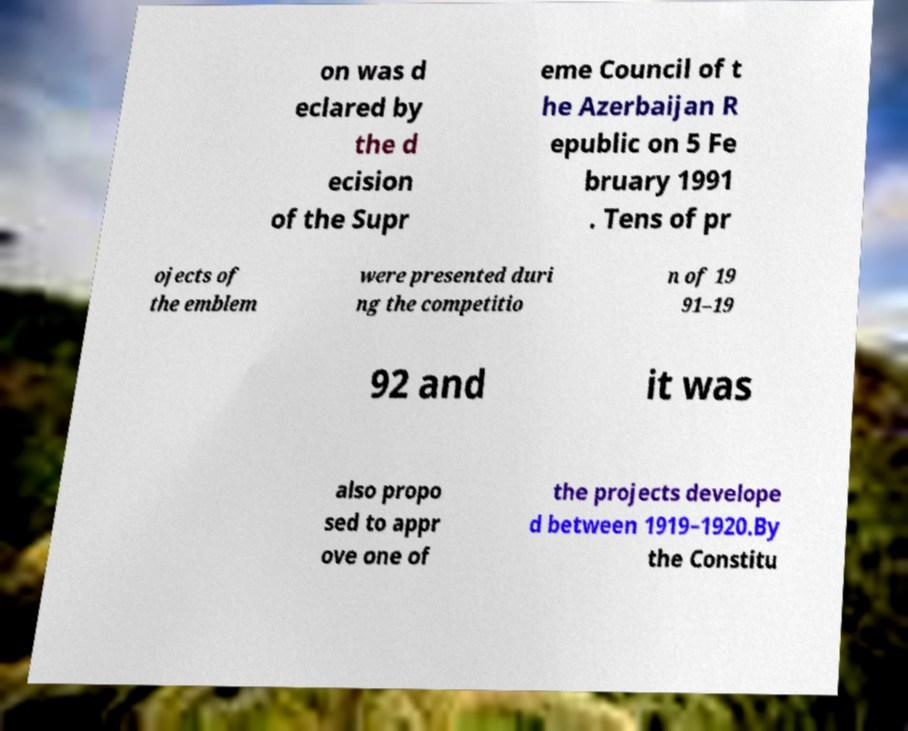What messages or text are displayed in this image? I need them in a readable, typed format. on was d eclared by the d ecision of the Supr eme Council of t he Azerbaijan R epublic on 5 Fe bruary 1991 . Tens of pr ojects of the emblem were presented duri ng the competitio n of 19 91–19 92 and it was also propo sed to appr ove one of the projects develope d between 1919–1920.By the Constitu 